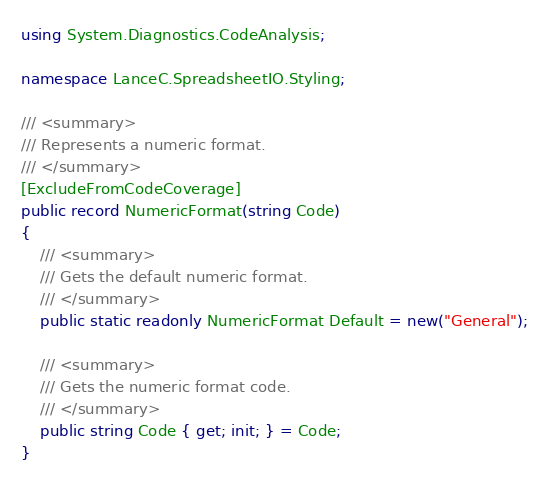<code> <loc_0><loc_0><loc_500><loc_500><_C#_>using System.Diagnostics.CodeAnalysis;

namespace LanceC.SpreadsheetIO.Styling;

/// <summary>
/// Represents a numeric format.
/// </summary>
[ExcludeFromCodeCoverage]
public record NumericFormat(string Code)
{
    /// <summary>
    /// Gets the default numeric format.
    /// </summary>
    public static readonly NumericFormat Default = new("General");

    /// <summary>
    /// Gets the numeric format code.
    /// </summary>
    public string Code { get; init; } = Code;
}
</code> 